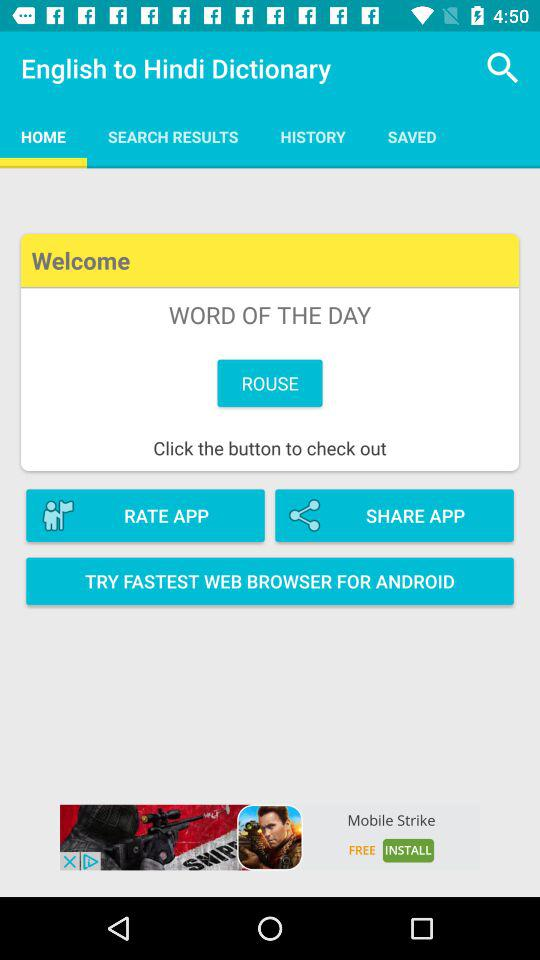What is the word of the day? The word of the day is "ROUSE". 